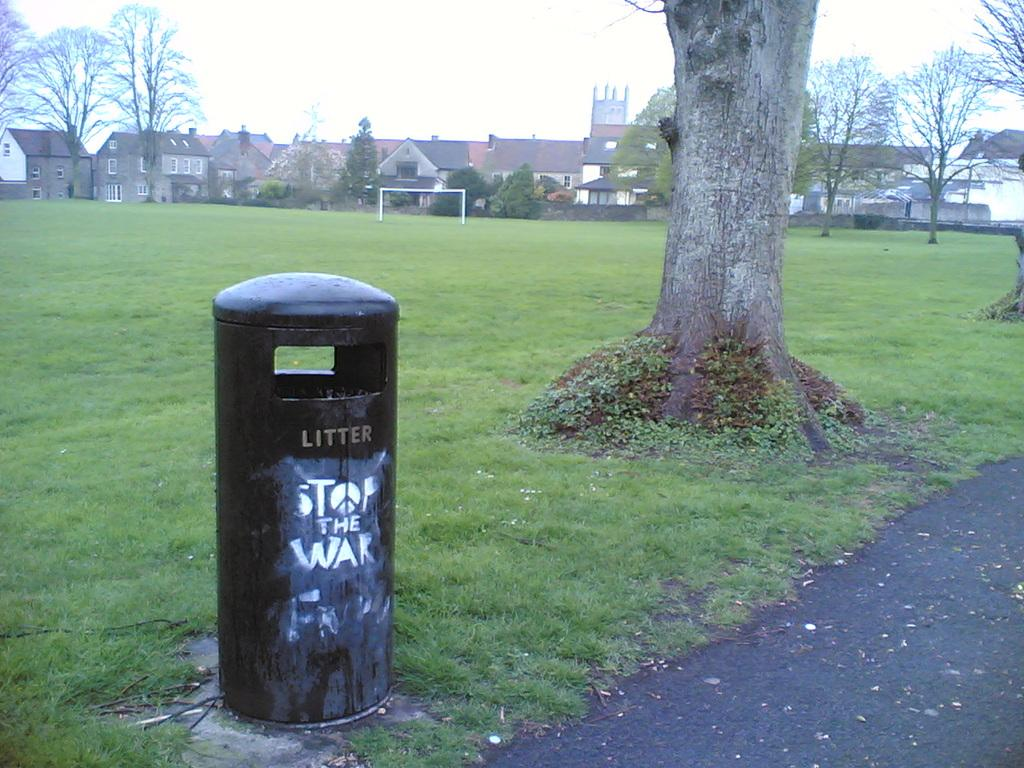<image>
Write a terse but informative summary of the picture. Black garbage can with the letters LITTER on it. 